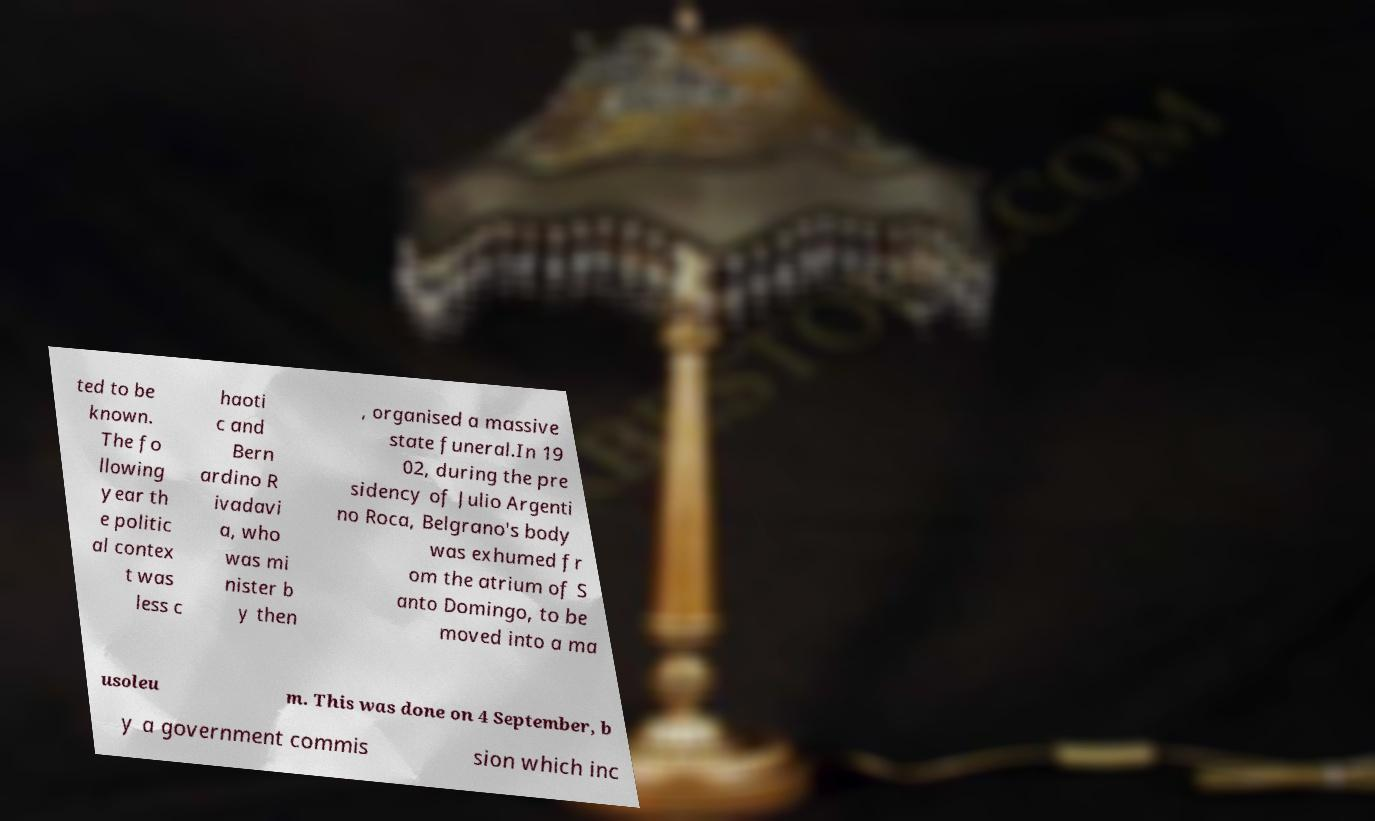For documentation purposes, I need the text within this image transcribed. Could you provide that? ted to be known. The fo llowing year th e politic al contex t was less c haoti c and Bern ardino R ivadavi a, who was mi nister b y then , organised a massive state funeral.In 19 02, during the pre sidency of Julio Argenti no Roca, Belgrano's body was exhumed fr om the atrium of S anto Domingo, to be moved into a ma usoleu m. This was done on 4 September, b y a government commis sion which inc 